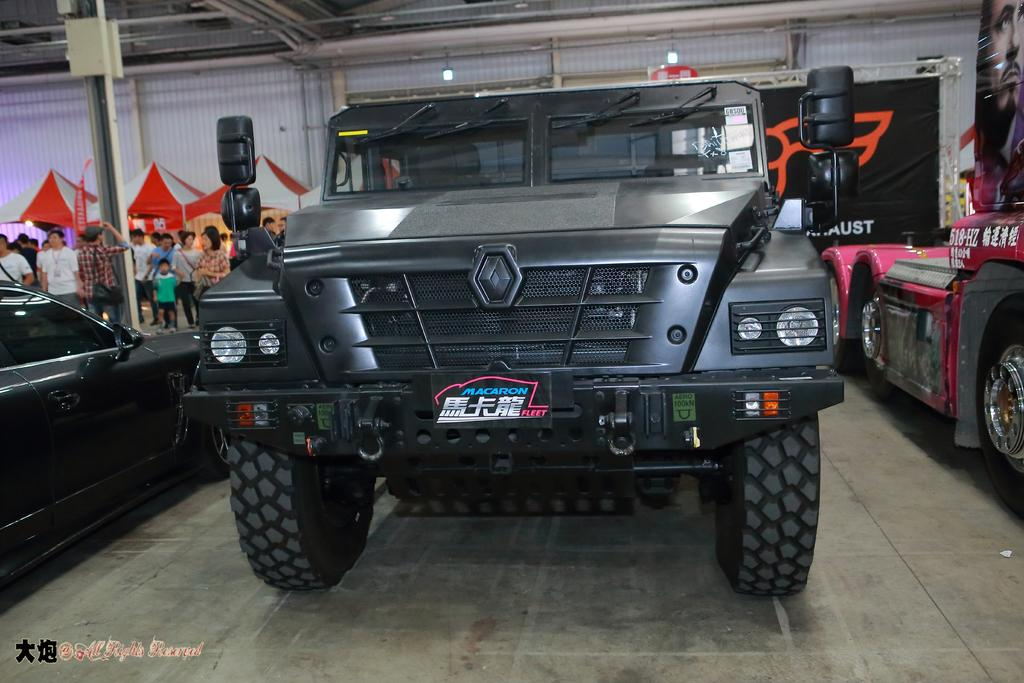What can be seen in the image? There are vehicles and tents in the image. Where are the vehicles located? The vehicles are in one place in the image. Are there any people present in the image? Yes, there are people standing in the image. What type of dock can be seen in the image? There is no dock present in the image. What is the maid doing in the image? There is no maid present in the image. 